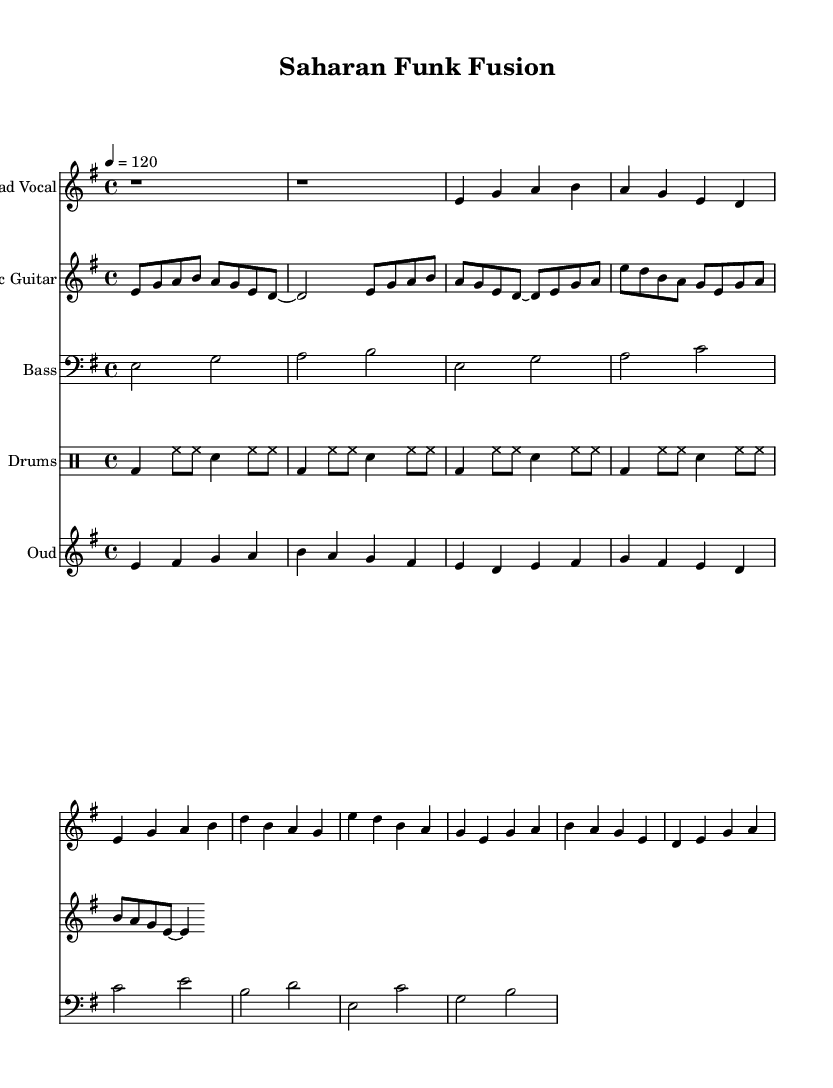What is the key signature of this music? The key signature is indicated by the sharp or flat signs after the clef at the beginning of the staff. In this case, there are no sharps or flats depicted, which means the music is in E minor, which has one sharp.
Answer: E minor What is the time signature of this music? The time signature is shown at the beginning of the score, where a fraction-like symbol appears. In this case, the score displays 4 over 4, meaning there are four beats in each measure and the quarter note gets one beat.
Answer: 4/4 What is the tempo marking? The tempo marking is found at the beginning of the score, which states the beats per minute. This score indicates a tempo of 120 beats per minute, meaning the music should be played briskly.
Answer: 120 What instrument primarily plays the bass line? The bass line is specified by the staff labeled ‘Bass’ at the bottom of the score. The notation there identifies that the bass guitar is primarily responsible for the bass line in this piece.
Answer: Bass Which instrument features a unique Middle-Eastern sound in this piece? The oud is notated on its own staff within the score, contributing a distinctive Middle-Eastern characteristic to the music. Recognizing the oud as part of the instrumentation indicates its unique sound.
Answer: Oud How is the drum pattern structured in this piece? The drum pattern is written in a specific rhythmic notation using bass drum (bd), hi-hat (hh), and snare (sn). Analyzing the drum notation reveals a consistent pattern of four measures repeating a similar rhythmic motif throughout the score.
Answer: Consistent 4-beat pattern 